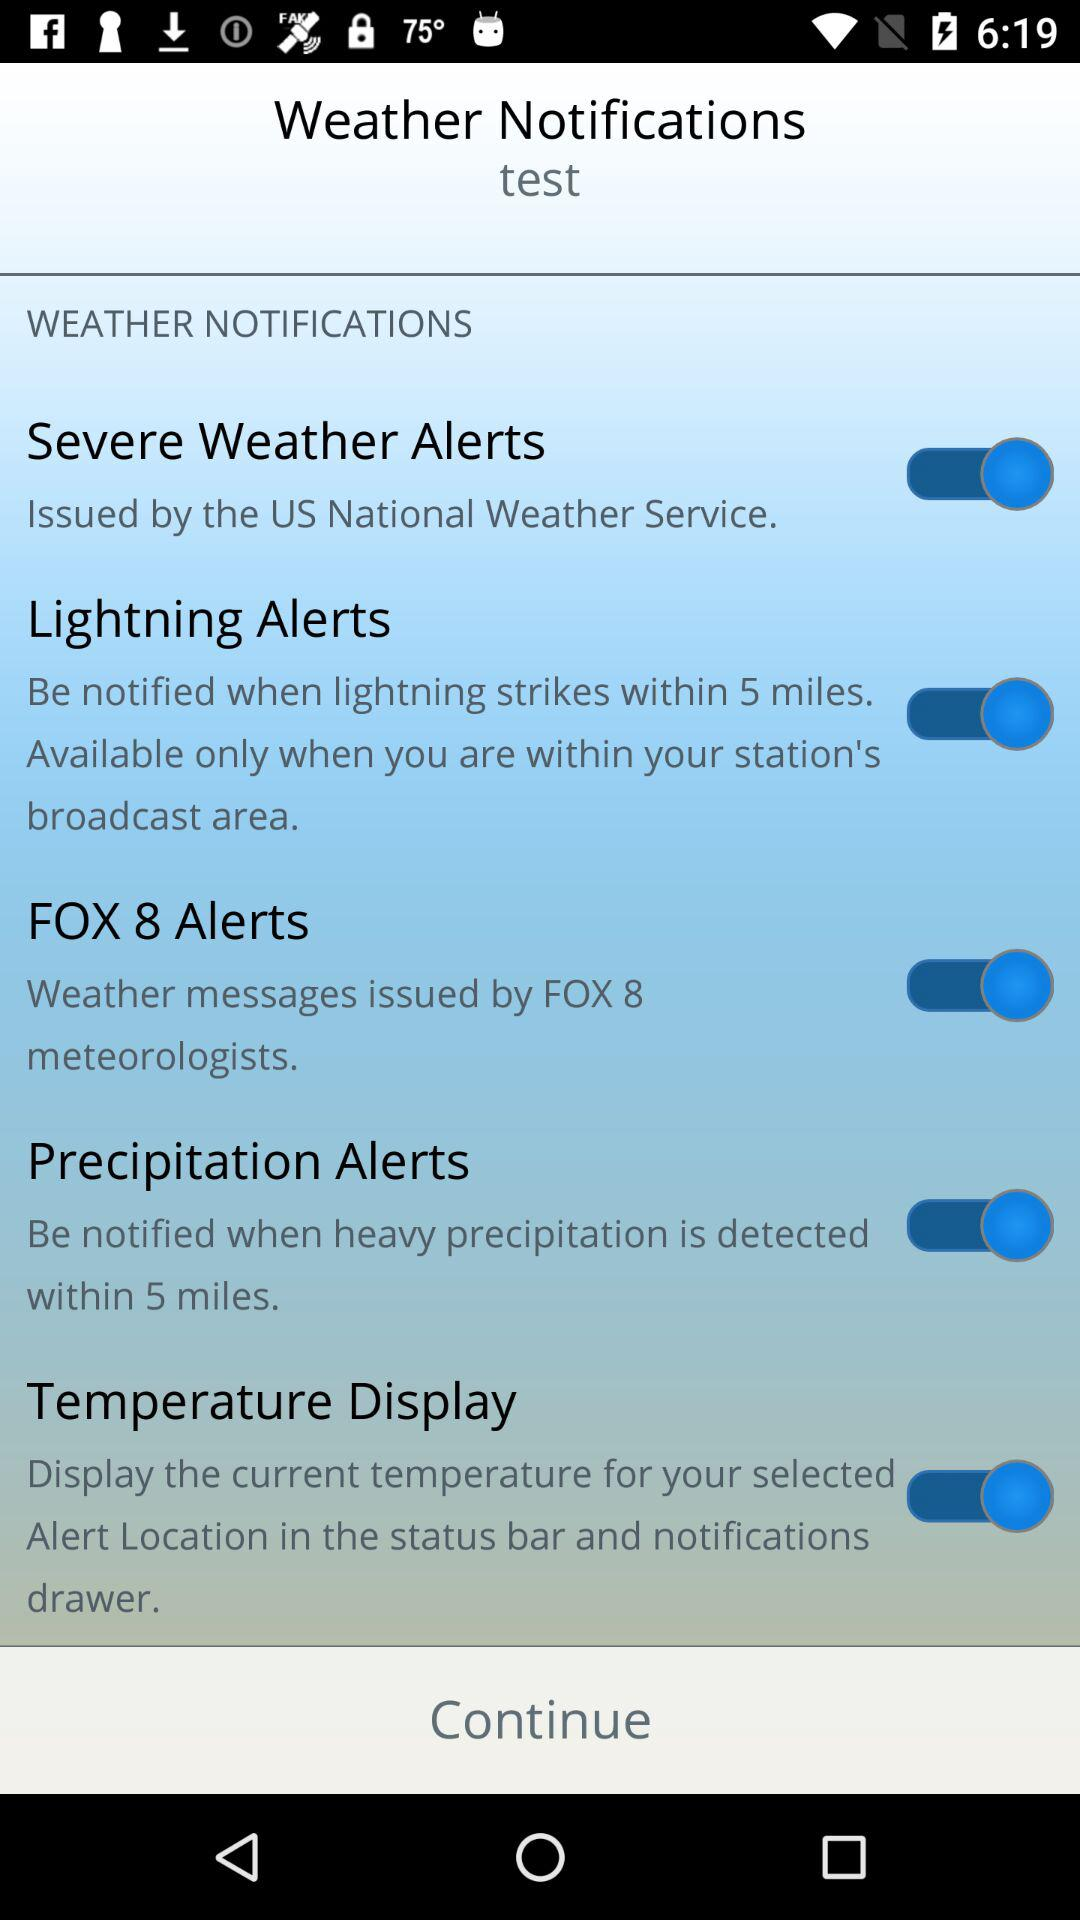What is the status of the "Temperature Display"? The status of the "Temperature Display" is "on". 